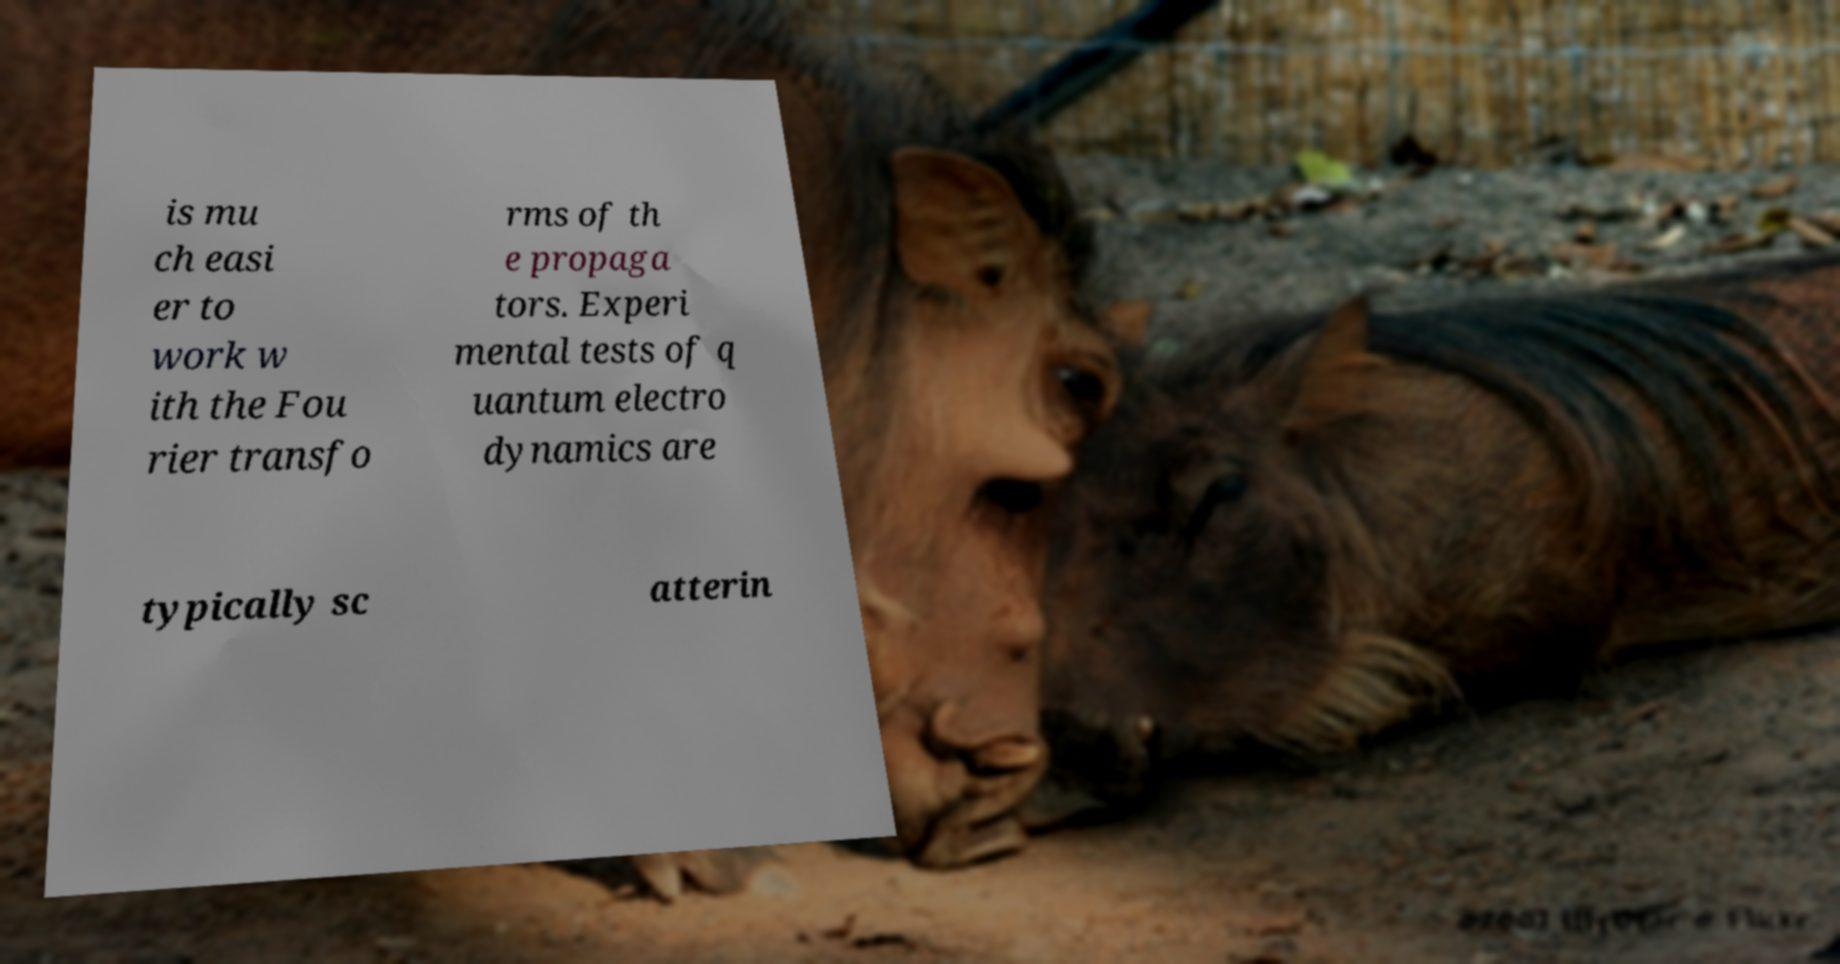Please identify and transcribe the text found in this image. is mu ch easi er to work w ith the Fou rier transfo rms of th e propaga tors. Experi mental tests of q uantum electro dynamics are typically sc atterin 